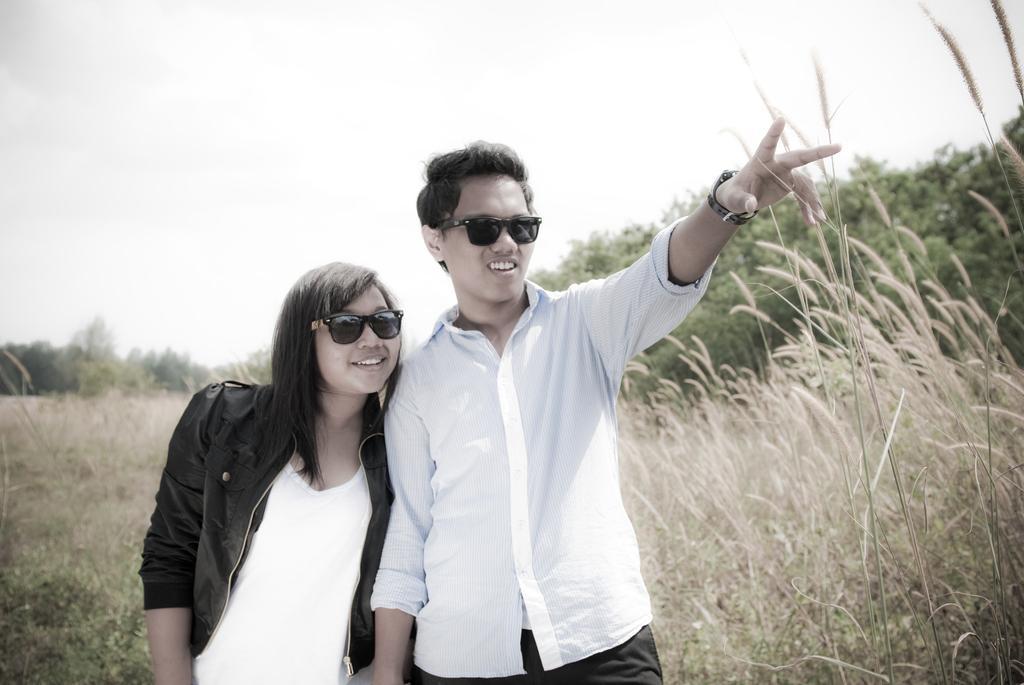Could you give a brief overview of what you see in this image? In this image, there are a few people, trees and plants. We can also see the sky. 